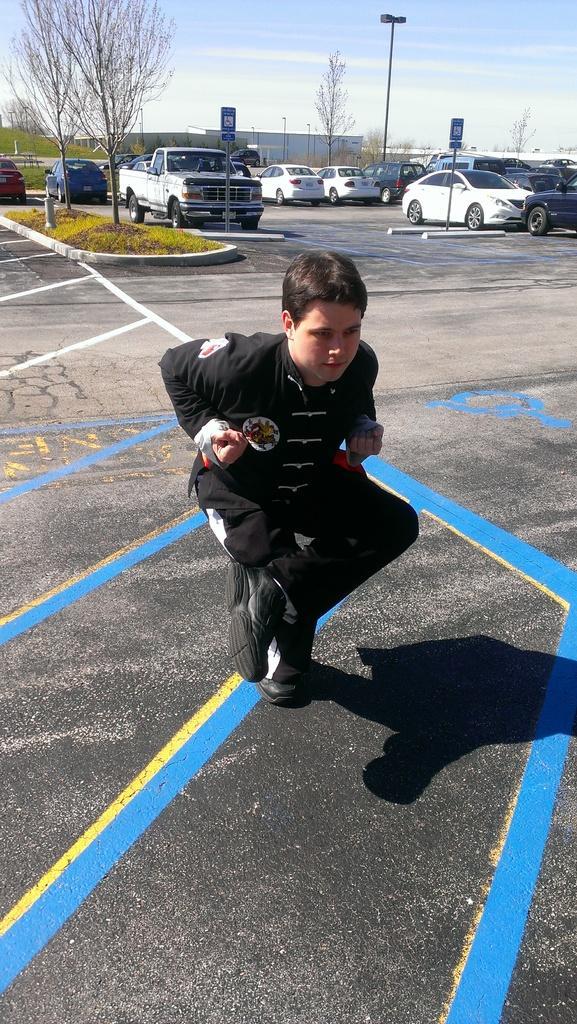Can you describe this image briefly? There is a boy in black color dress squatting on a road on which, there are blue, yellow and white color marks. In the background, there are vehicles in different color on the road, there are trees, there is grass on the divider and there are clouds in the sky. 